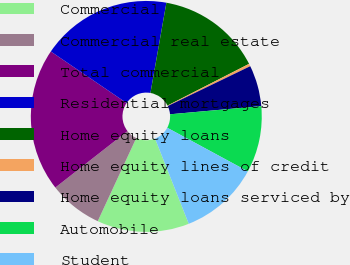Convert chart to OTSL. <chart><loc_0><loc_0><loc_500><loc_500><pie_chart><fcel>Commercial<fcel>Commercial real estate<fcel>Total commercial<fcel>Residential mortgages<fcel>Home equity loans<fcel>Home equity lines of credit<fcel>Home equity loans serviced by<fcel>Automobile<fcel>Student<nl><fcel>12.9%<fcel>7.53%<fcel>20.07%<fcel>18.28%<fcel>14.69%<fcel>0.36%<fcel>5.74%<fcel>9.32%<fcel>11.11%<nl></chart> 